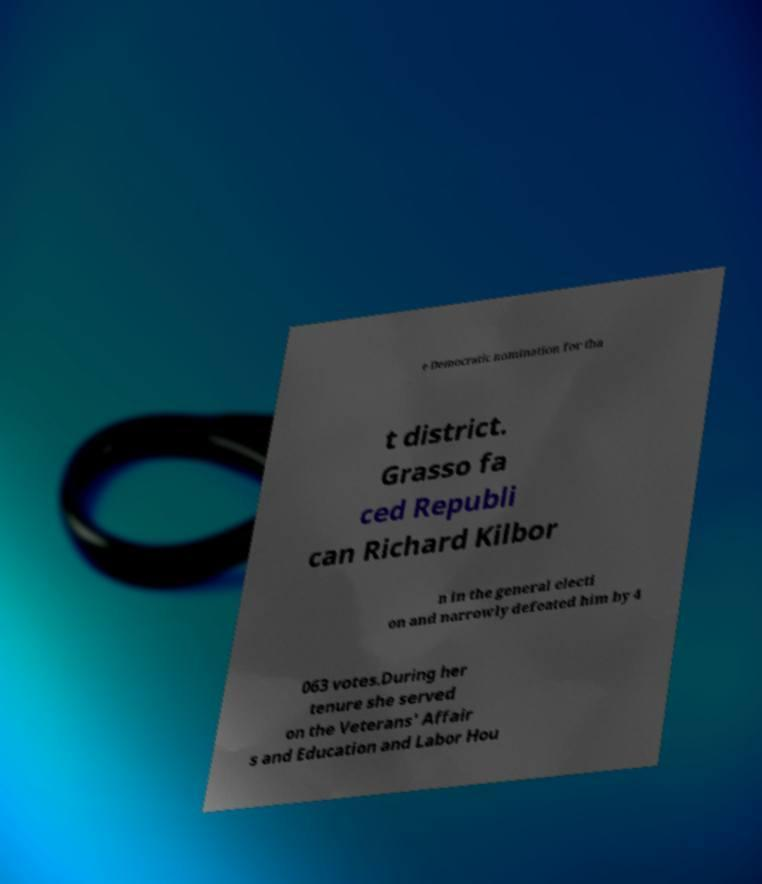I need the written content from this picture converted into text. Can you do that? e Democratic nomination for tha t district. Grasso fa ced Republi can Richard Kilbor n in the general electi on and narrowly defeated him by 4 063 votes.During her tenure she served on the Veterans' Affair s and Education and Labor Hou 